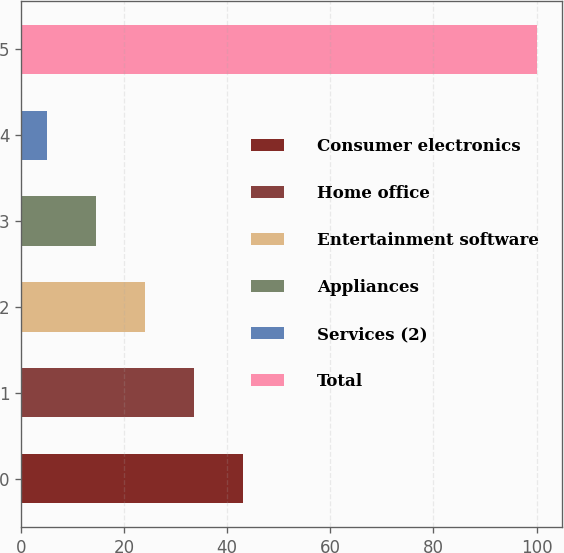Convert chart. <chart><loc_0><loc_0><loc_500><loc_500><bar_chart><fcel>Consumer electronics<fcel>Home office<fcel>Entertainment software<fcel>Appliances<fcel>Services (2)<fcel>Total<nl><fcel>43<fcel>33.5<fcel>24<fcel>14.5<fcel>5<fcel>100<nl></chart> 